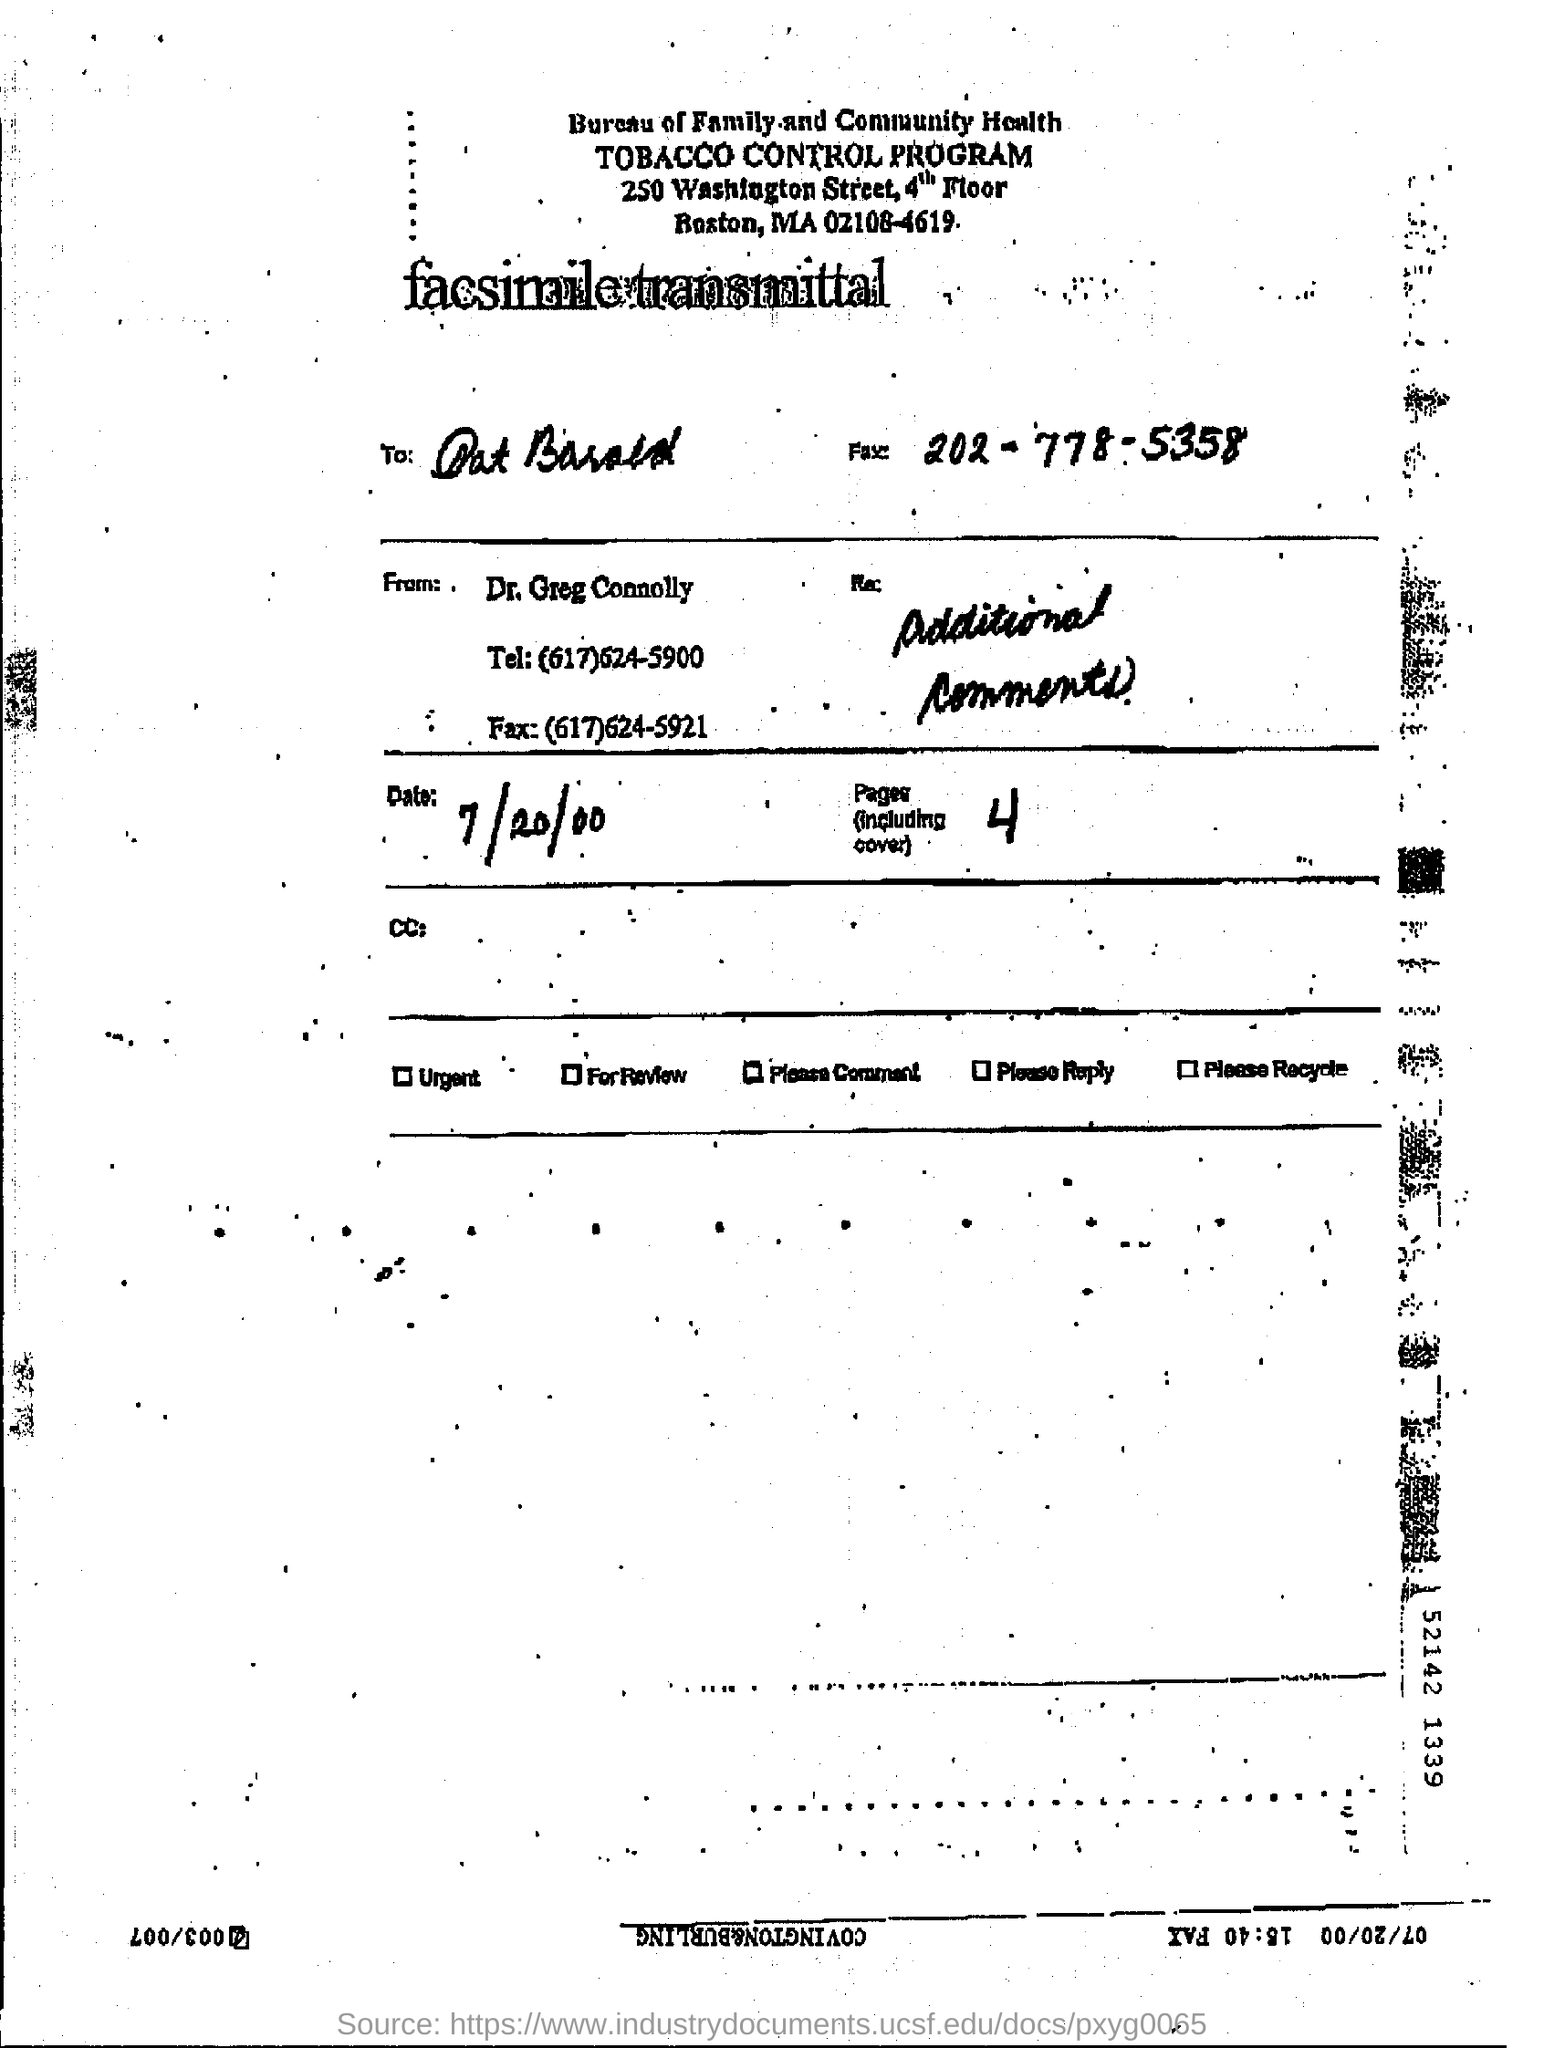List a handful of essential elements in this visual. There are 4 pages in total, including the cover page. The name of the program aimed at controlling the use of tobacco is the tobacco control program. The fax number provided is 202-778-5358. The date mentioned on the page is 7/20/00. 